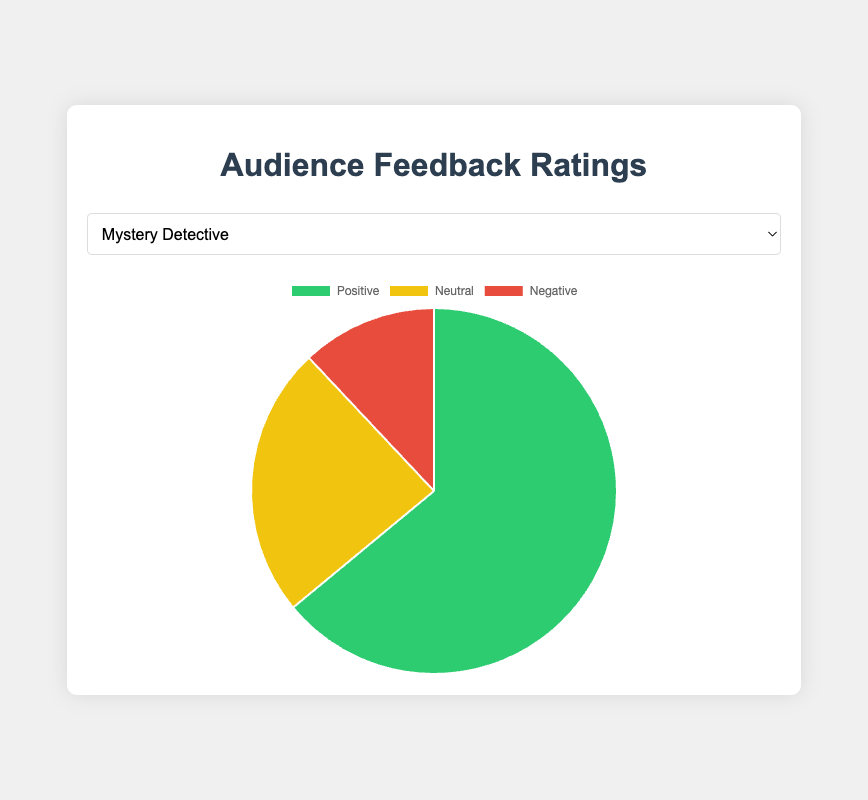Which show has the highest percentage of positive feedback? The percentage of positive feedback is calculated by dividing the positive feedback count by the total feedback count for each show. Comparing these percentages, we find that "Sports Highlights" has the highest percentage.
Answer: Sports Highlights Which show has the largest difference between positive and negative feedback? We calculate the difference by subtracting the negative feedback from the positive feedback for each show. The show with the largest difference is "Sports Highlights" (650 - 90 = 560).
Answer: Sports Highlights What’s the total number of neutral feedback across all shows? Sum the neutral feedback numbers for all shows: 120 + 100 + 130 + 200 + 180 + 220 + 140 + 90 + 110 + 160 = 1450.
Answer: 1450 Which show has the smallest portion of negative feedback in its pie chart? The portion of negative feedback is smallest in "Travel Diaries," which has only 30 negative feedbacks out of a total of 490 feedbacks. This yields the smallest ratio when compared.
Answer: Travel Diaries How does the positive feedback of "Music Legends" compare to that of "Mystery Detective"? Compare the positive feedback counts: "Music Legends" has 480 positive feedbacks, while "Mystery Detective" has 320.
Answer: Music Legends has more positive feedback What is the average number of positive feedbacks for all shows? Calculate the sum of positive feedback counts for all shows and divide by the number of shows: (320 + 450 + 290 + 500 + 650 + 400 + 310 + 370 + 480 + 530) / 10 = 4300 / 10.
Answer: 430 Which show has the highest visual portion of neutral feedback? Visually compare the pie chart segments. "Comedy Night" has the largest neutral feedback count, 220, and thus the largest visual portion.
Answer: Comedy Night If you combined the positive feedback of "Daily News Roundup" and "Tech Innovations," how many total positive feedbacks would that be? Sum the positive feedbacks: 500 (Daily News Roundup) + 310 (Tech Innovations) = 810.
Answer: 810 Which show has the closest number of neutral and negative feedbacks? Look for the smallest difference between the neutral and negative feedback counts. "Tech Innovations" has 140 neutral and 50 negative, so the difference is 90. This is the smallest difference among all shows.
Answer: Tech Innovations What percentage of total feedback is negative for the show "Wildlife Adventures"? Calculate the total feedback (528 + 160 + 40 = 730) and divide the negative feedback by the total feedback, then multiply by 100: (40 / 730) * 100 = 5.48%.
Answer: 5.48% 